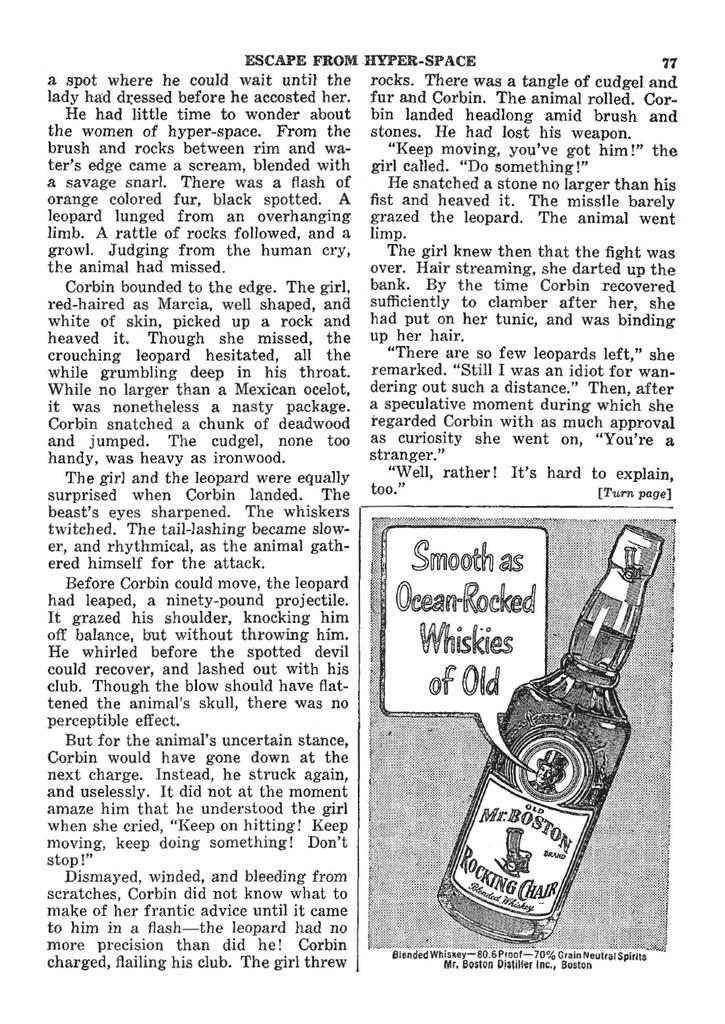What should you escape from?
Your answer should be compact. Hyper-space. What did the guy on the bottle say about the whiskey?
Give a very brief answer. Smooth as ocean-rocked whiskies of old. 